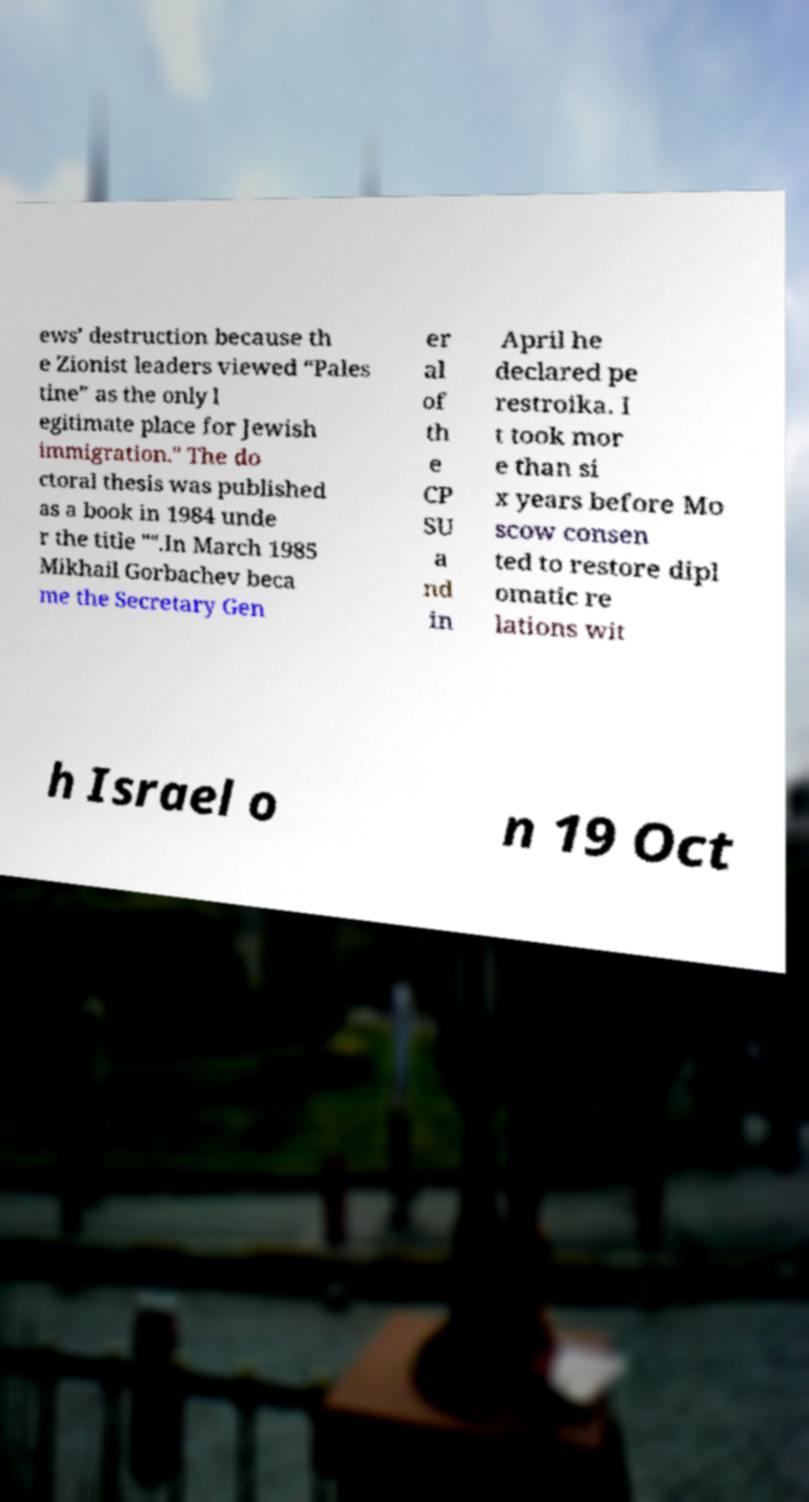Can you read and provide the text displayed in the image?This photo seems to have some interesting text. Can you extract and type it out for me? ews’ destruction because th e Zionist leaders viewed “Pales tine” as the only l egitimate place for Jewish immigration." The do ctoral thesis was published as a book in 1984 unde r the title "".In March 1985 Mikhail Gorbachev beca me the Secretary Gen er al of th e CP SU a nd in April he declared pe restroika. I t took mor e than si x years before Mo scow consen ted to restore dipl omatic re lations wit h Israel o n 19 Oct 